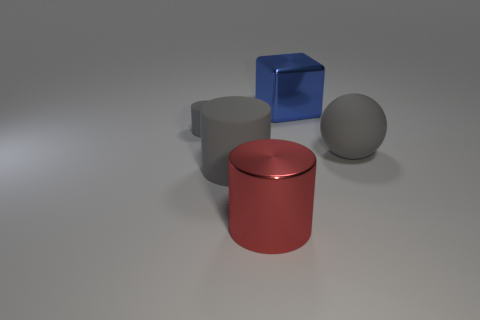Does the big sphere have the same color as the big rubber cylinder? Yes, both the big sphere and the big rubber cylinder have a similar shade of gray, reflecting a sleek, monochromatic appearance. 